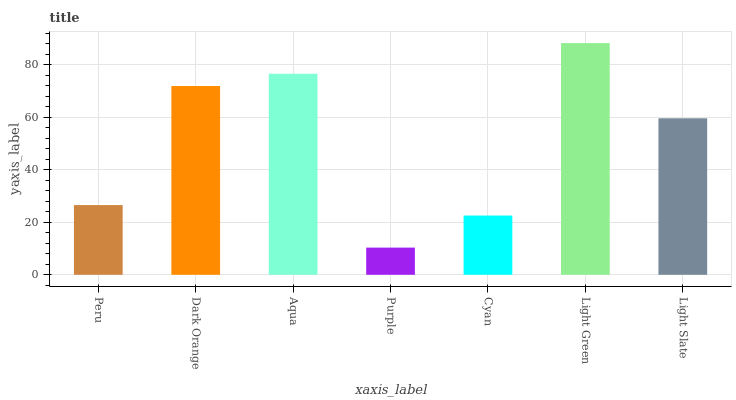Is Purple the minimum?
Answer yes or no. Yes. Is Light Green the maximum?
Answer yes or no. Yes. Is Dark Orange the minimum?
Answer yes or no. No. Is Dark Orange the maximum?
Answer yes or no. No. Is Dark Orange greater than Peru?
Answer yes or no. Yes. Is Peru less than Dark Orange?
Answer yes or no. Yes. Is Peru greater than Dark Orange?
Answer yes or no. No. Is Dark Orange less than Peru?
Answer yes or no. No. Is Light Slate the high median?
Answer yes or no. Yes. Is Light Slate the low median?
Answer yes or no. Yes. Is Dark Orange the high median?
Answer yes or no. No. Is Cyan the low median?
Answer yes or no. No. 